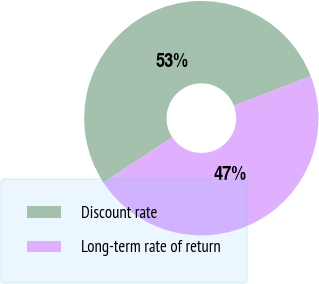Convert chart. <chart><loc_0><loc_0><loc_500><loc_500><pie_chart><fcel>Discount rate<fcel>Long-term rate of return<nl><fcel>53.44%<fcel>46.56%<nl></chart> 